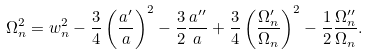Convert formula to latex. <formula><loc_0><loc_0><loc_500><loc_500>\Omega ^ { 2 } _ { n } = w _ { n } ^ { 2 } - \frac { 3 } { 4 } \left ( \frac { a ^ { \prime } } { a } \right ) ^ { 2 } - \frac { 3 } { 2 } \frac { a ^ { \prime \prime } } { a } + \frac { 3 } { 4 } \left ( \frac { \Omega _ { n } ^ { \prime } } { \Omega _ { n } } \right ) ^ { 2 } - \frac { 1 } { 2 } \frac { \Omega ^ { \prime \prime } _ { n } } { \Omega _ { n } } .</formula> 